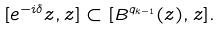Convert formula to latex. <formula><loc_0><loc_0><loc_500><loc_500>[ e ^ { - i \delta } z , z ] \subset [ { B } ^ { q _ { k - 1 } } ( z ) , z ] .</formula> 